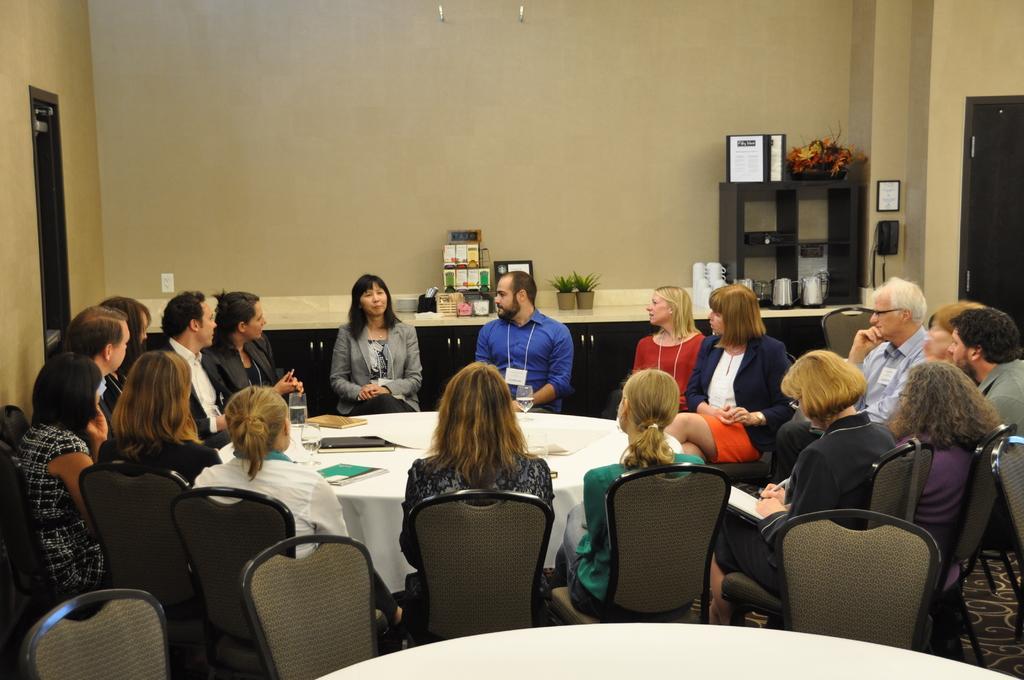Please provide a concise description of this image. Around the table there are many people sitting on the chair. On the table there are some files, glasses, papers. In the background there is a table. On the table there are two plants, boxes , cupboards, jars. To the right side there is a Telephone, some leaves, frames. And to the right corner there is a door. To the left corner there is also a door. 